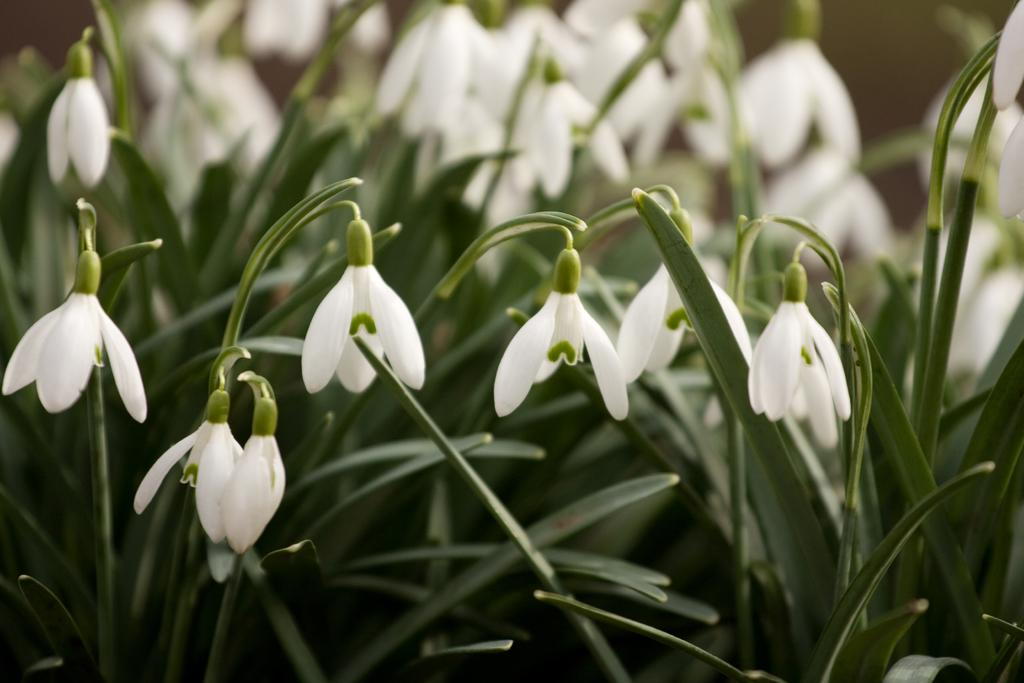What is the main subject of the image? The main subject of the image is many plants. What specific feature do the plants have? The plants have flowers. What color are the flowers? The flowers are white in color. Can you describe the background of the image? The background of the image is blurred. What type of shock can be seen on the van in the image? There is no van present in the image, so it is not possible to determine if there is any shock on a van. 